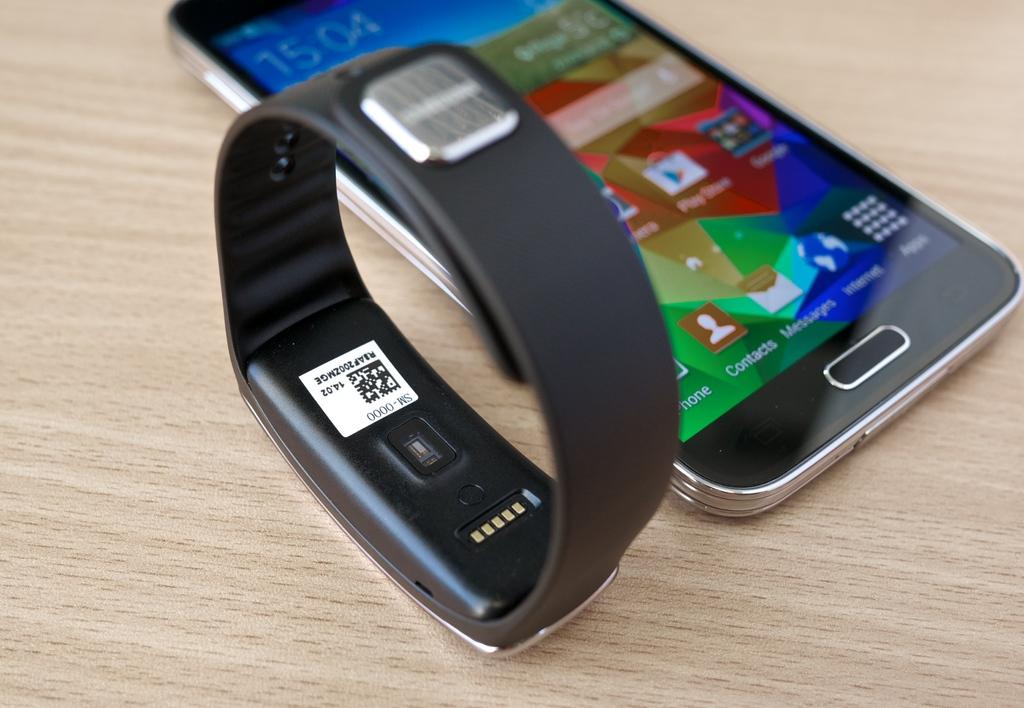Provide a one-sentence caption for the provided image. A fitbit and smart phone displaying the time of 15:04. 